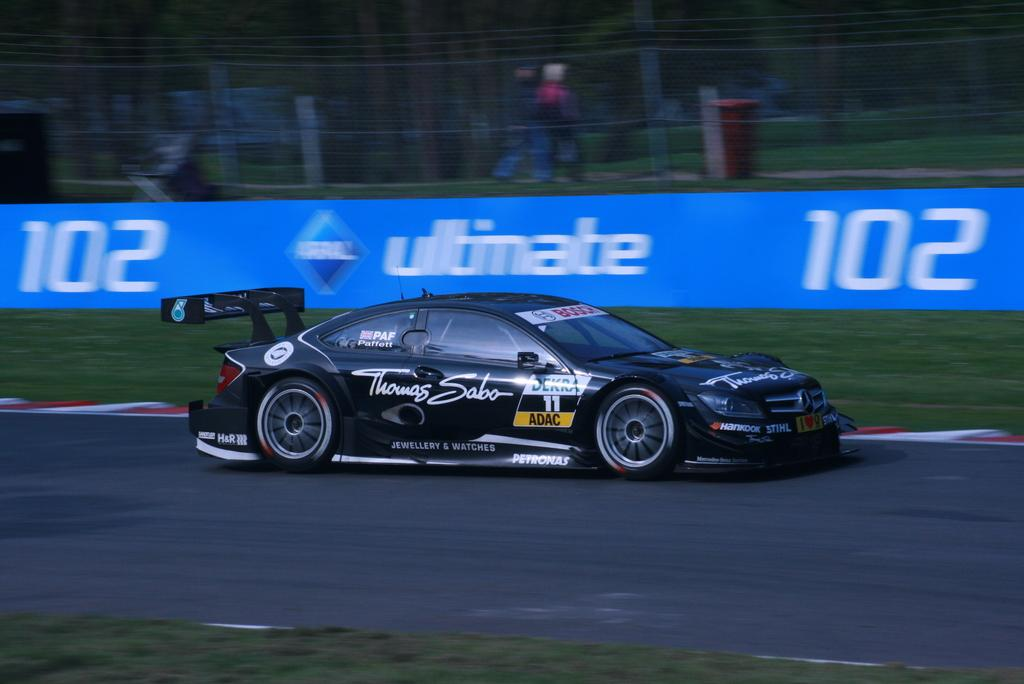What type of vehicle is in the image? There is a sports car in the image. Where is the car located? The car is on the road. Is the car moving or stationary in the image? The car is in motion. What can be seen in the background of the image? There is a banner in the background of the image. What type of cable is being used to control the van in the image? There is no van present in the image, and therefore no cable or control mechanism can be observed. 